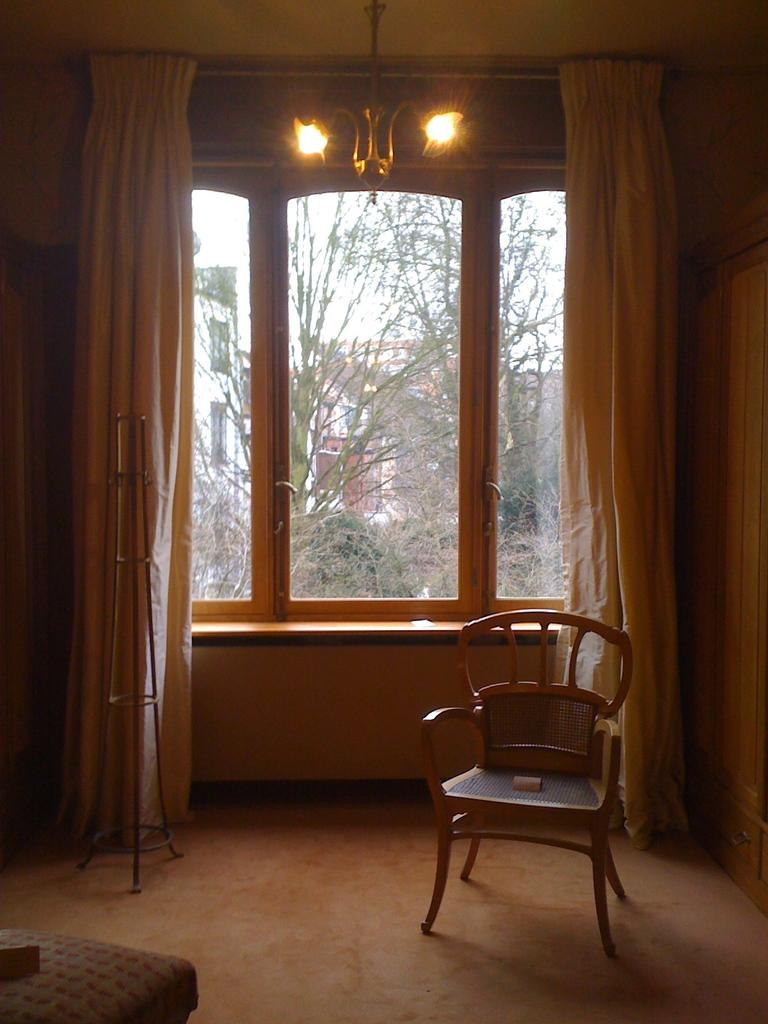What can be seen in the image that allows light to enter a room? There is a window in the image. What is covering the window in the image? The window contains curtains. What is the source of light at the top of the image? There is a light at the top of the image. What type of furniture is located in the bottom right of the image? There is a chair in the bottom right of the image. What type of stocking is hanging from the window in the image? There is no stocking hanging from the window in the image. 